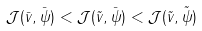Convert formula to latex. <formula><loc_0><loc_0><loc_500><loc_500>\mathcal { J } ( \bar { v } , \bar { \psi } ) < \mathcal { J } ( \tilde { v } , \bar { \psi } ) < \mathcal { J } ( \tilde { v } , \tilde { \psi } )</formula> 